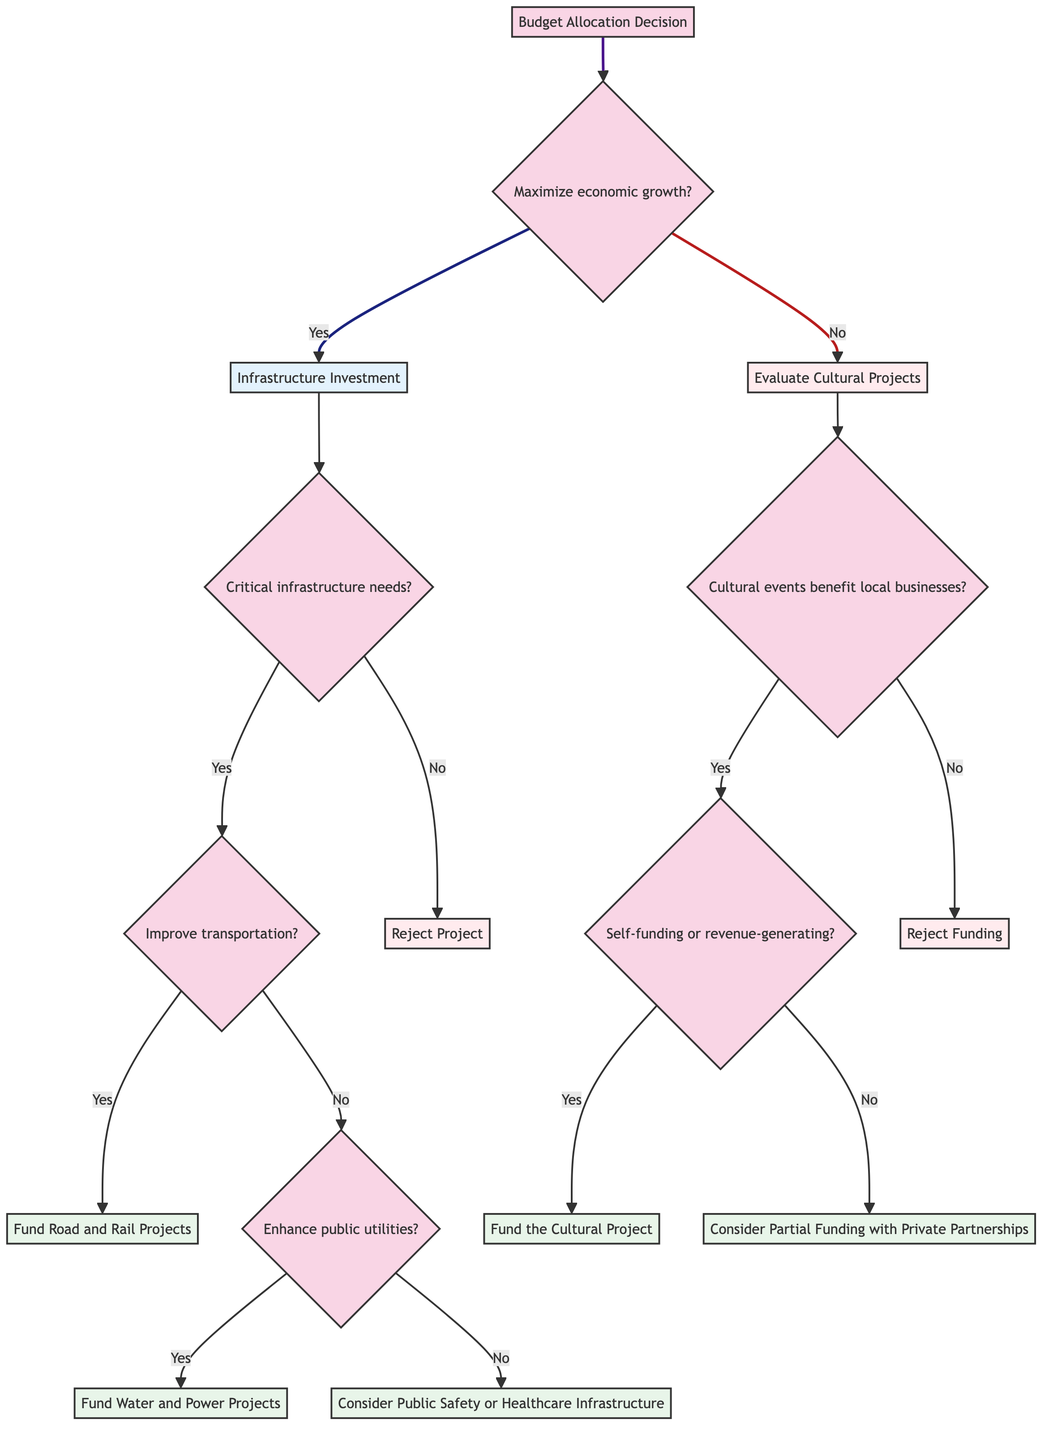Is the first question about maximizing economic growth? The diagram starts with the question regarding maximizing economic growth. The first node presents this main decision point.
Answer: Yes How many main paths are present in the decision tree? The decision tree branches into two main paths: one for Infrastructure Investment and one for Evaluate Cultural Projects, indicating there are two primary outcomes from the first question.
Answer: 2 In the Infrastructure Investment path, what type of project is evaluated after addressing critical infrastructure needs? After determining if the project addresses critical infrastructure needs, the next decision involves whether it improves transportation, leading to further evaluation of specific projects.
Answer: transportation What happens if the project does not address critical infrastructure needs? If the project does not address critical infrastructure needs, the diagram indicates that the project is rejected, leading to no further actions.
Answer: Reject Project If cultural events do not benefit local businesses, what is the recommendation? According to the decision tree, if cultural events do not significantly benefit local businesses, the funding for cultural projects is rejected, leaving no options for funding options.
Answer: Reject Funding What decision is made if a cultural project is self-funding? If a cultural project is found to be self-funding or revenue-generating, funding for that cultural project is approved as indicated in the corresponding node of the diagram.
Answer: Fund the Cultural Project If the project enhances public utilities, what is the next action? Upon confirming that the project enhances public utilities, the next action and funding decision is to fund water and power projects, as outlined in the decision tree path.
Answer: Fund Water and Power Projects How many questions are there in the Evaluate Cultural Projects path? The Evaluate Cultural Projects path includes two main questions: one about the benefit to local businesses and the other about whether the event is self-funding, accounting for a total of two questions in this segment.
Answer: 2 